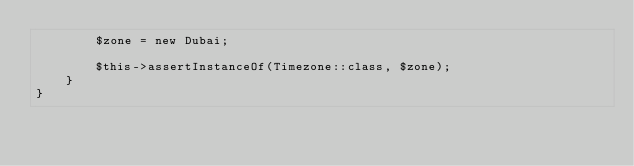Convert code to text. <code><loc_0><loc_0><loc_500><loc_500><_PHP_>        $zone = new Dubai;

        $this->assertInstanceOf(Timezone::class, $zone);
    }
}
</code> 